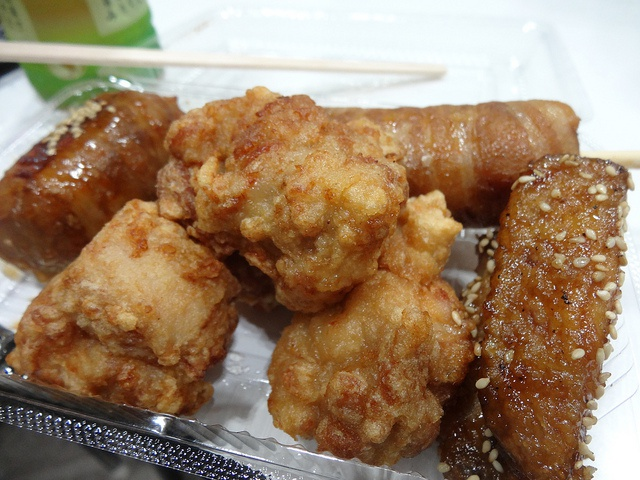Describe the objects in this image and their specific colors. I can see dining table in darkgreen, white, darkgray, olive, and green tones, hot dog in darkgreen, tan, brown, and maroon tones, and bottle in darkgreen, olive, and darkgray tones in this image. 